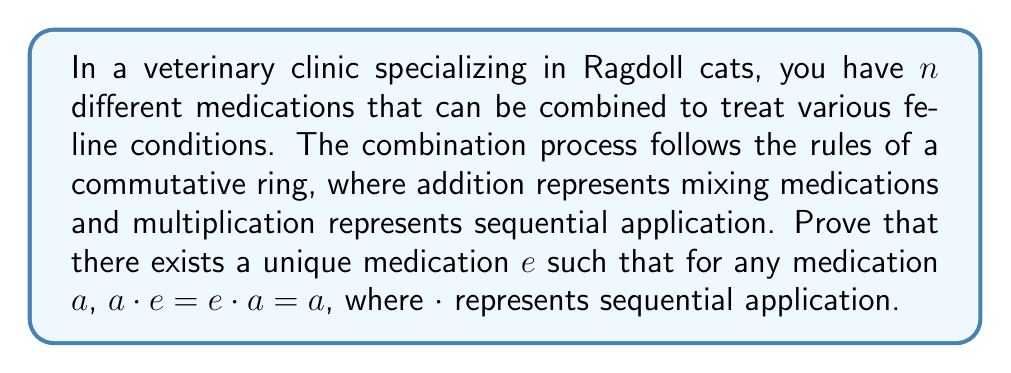Show me your answer to this math problem. Let's prove this step by step:

1) First, we need to show the existence of an identity element.

   Let $e_1$ and $e_2$ be two identity elements in the ring. This means:
   
   For any element $a$ in the ring:
   $a \cdot e_1 = e_1 \cdot a = a$ and $a \cdot e_2 = e_2 \cdot a = a$

2) Now, let's consider $e_1 \cdot e_2$:
   
   $e_1 \cdot e_2 = e_1$ (because $e_2$ is an identity)
   $e_1 \cdot e_2 = e_2$ (because $e_1$ is an identity)

3) Therefore, $e_1 = e_2$

This proves that if an identity element exists, it must be unique.

4) To prove existence, we can use the axioms of a ring:

   - The set of medications forms an abelian group under addition with identity 0.
   - Multiplication is associative and distributive over addition.
   - There exists a multiplicative identity element $e$.

5) The multiplicative identity $e$ has the property that for any medication $a$:

   $a \cdot e = e \cdot a = a$

6) The commutativity of multiplication in this ring ensures that:

   $a \cdot e = e \cdot a$

Therefore, we have proved both the existence and uniqueness of the multiplicative identity in this commutative ring of medications.
Answer: There exists a unique multiplicative identity $e$ in the commutative ring of medications such that for any medication $a$, $a \cdot e = e \cdot a = a$. 